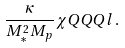Convert formula to latex. <formula><loc_0><loc_0><loc_500><loc_500>\frac { \kappa } { M _ { \ast } ^ { 2 } M _ { p } } \chi Q Q Q l \, .</formula> 